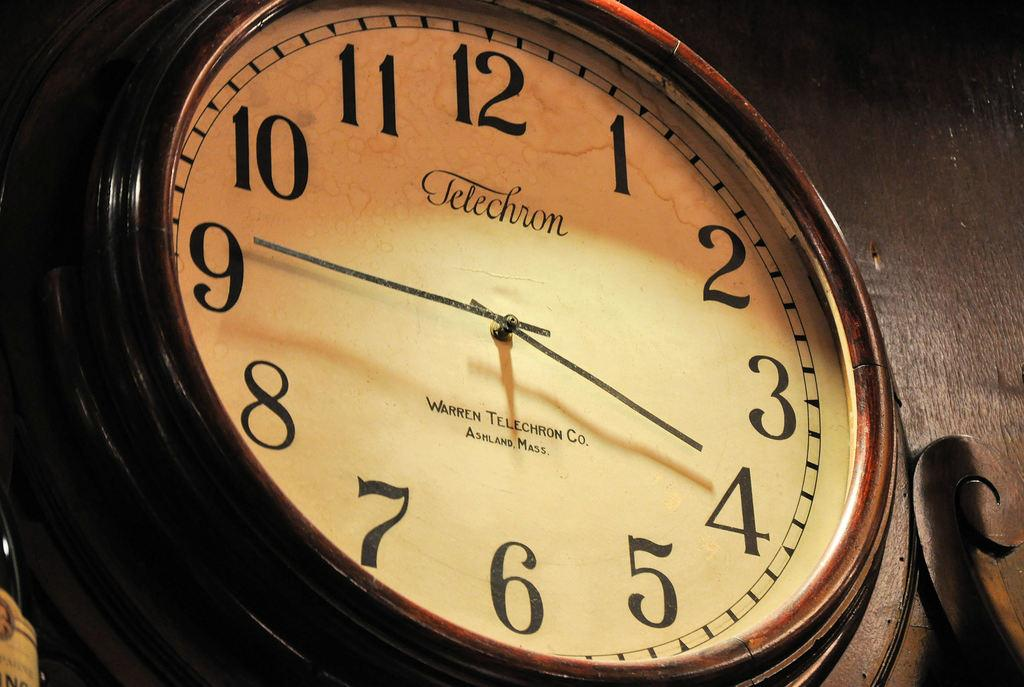Provide a one-sentence caption for the provided image. A clock made by Telechron shows that the time is 3:45. 